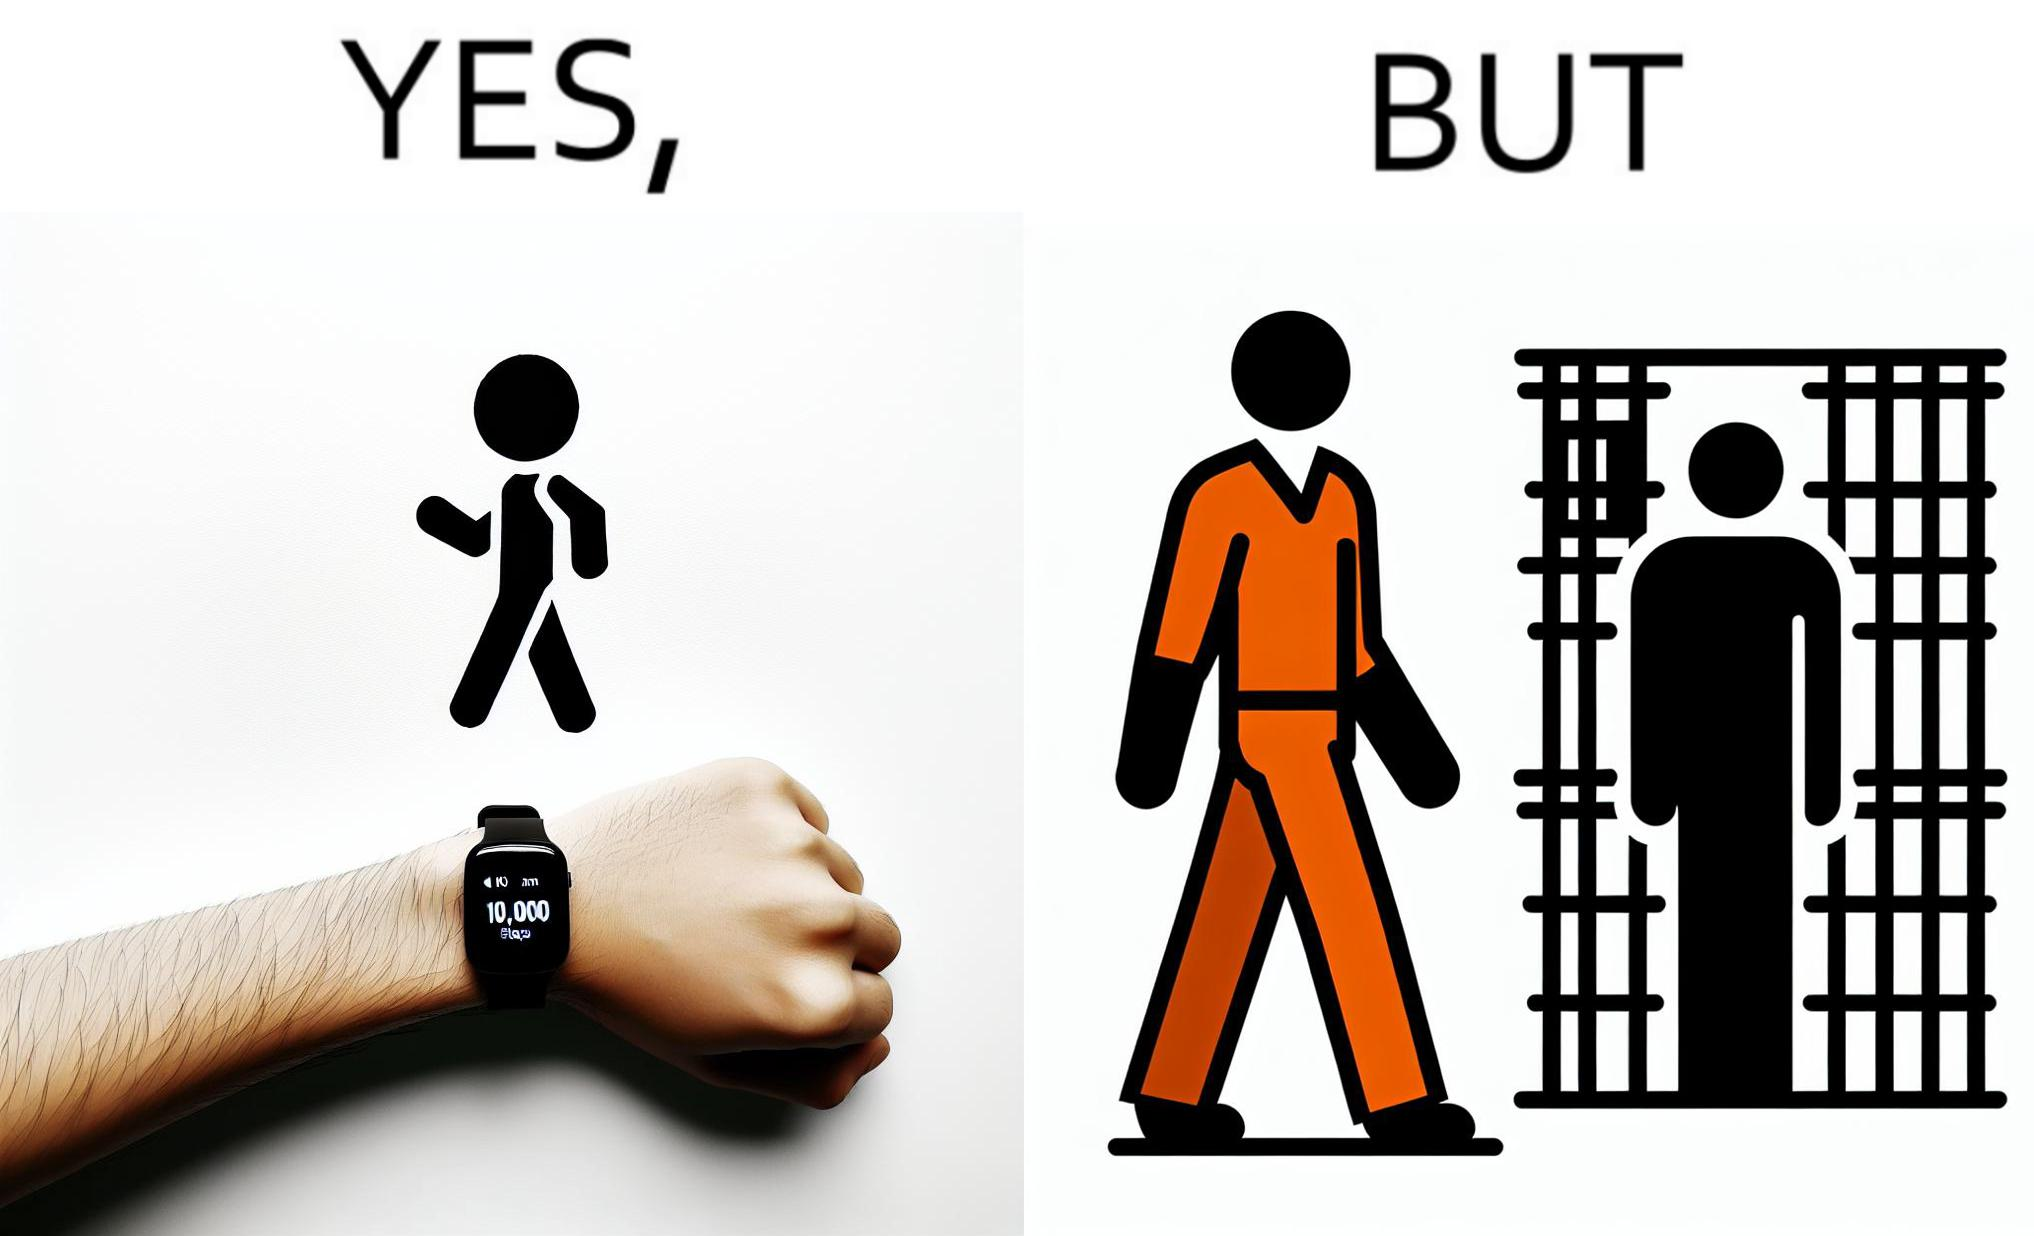Would you classify this image as satirical? Yes, this image is satirical. 